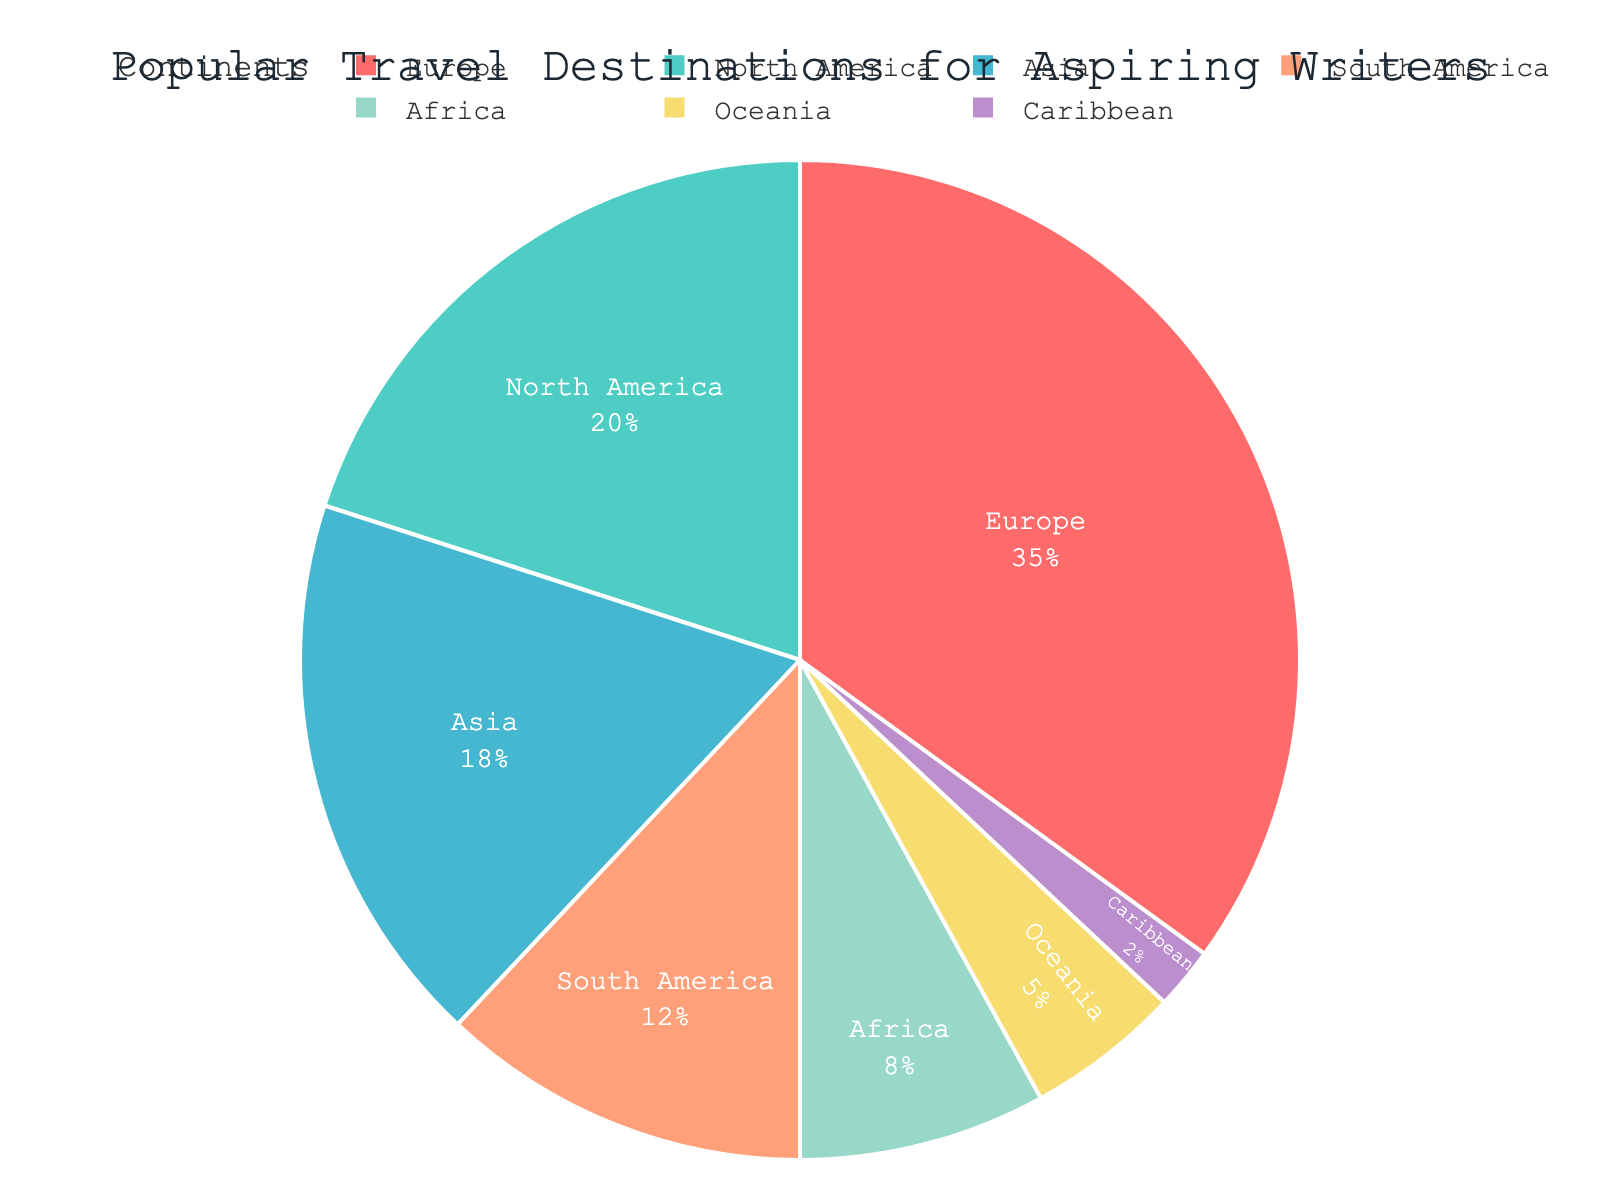Which continent is the most popular travel destination for aspiring writers? The largest segment in the pie chart represents the most popular travel destination. This segment is labeled as Europe.
Answer: Europe Which continent is the least popular travel destination for aspiring writers? The smallest segment in the pie chart represents the least popular travel destination. This segment is labeled as the Caribbean.
Answer: Caribbean How much more popular is Europe compared to Oceania? To determine this, we subtract Oceania's percentage from Europe's percentage. Europe has 35%, and Oceania has 5%. The difference is 35% - 5% = 30%.
Answer: 30% What is the combined percentage of North America and South America as travel destinations for aspiring writers? We need to add the percentages of North America and South America. North America has 20%, and South America has 12%. The combined percentage is 20% + 12% = 32%.
Answer: 32% Which continents have a popularity percentage greater than 10% but less than 30%? By examining the pie chart, we see that North America with 20%, Asia with 18%, and South America with 12% are the continents within this range.
Answer: North America, Asia, South America How does the popularity of Asia compare to that of Africa? Asia has a segment with 18%, and Africa has a segment with 8%. Since 18% is greater than 8%, Asia is more popular than Africa.
Answer: Asia is more popular than Africa What is the combined percentage for continents other than Europe? First, we sum the percentages of North America (20%), Asia (18%), South America (12%), Africa (8%), Oceania (5%), and Caribbean (2%). The total is 20% + 18% + 12% + 8% + 5% + 2% = 65%.
Answer: 65% Which color represents the continent with the highest percentage? The largest segment representing Europe is colored red.
Answer: Red 